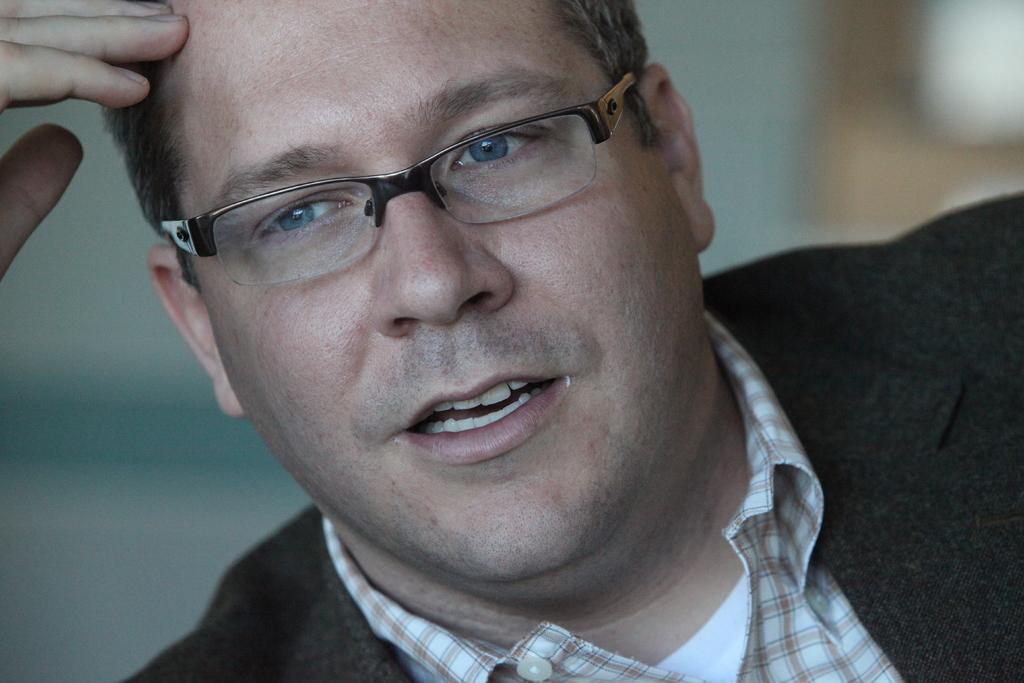Describe this image in one or two sentences. In this image we can see a man and he wore spectacles to his eyes. In the background the image is blur. 